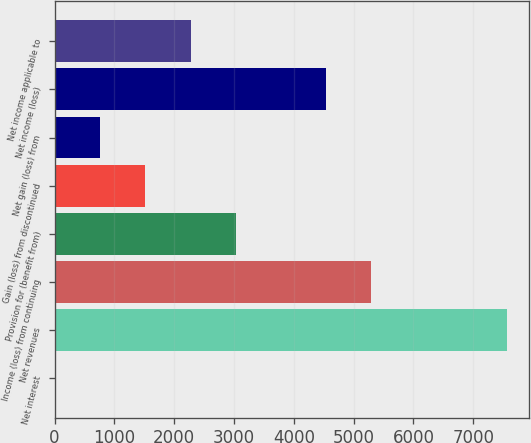Convert chart to OTSL. <chart><loc_0><loc_0><loc_500><loc_500><bar_chart><fcel>Net interest<fcel>Net revenues<fcel>Income (loss) from continuing<fcel>Provision for (benefit from)<fcel>Gain (loss) from discontinued<fcel>Net gain (loss) from<fcel>Net income (loss)<fcel>Net income applicable to<nl><fcel>7<fcel>7558<fcel>5292.7<fcel>3027.4<fcel>1517.2<fcel>762.1<fcel>4537.6<fcel>2272.3<nl></chart> 